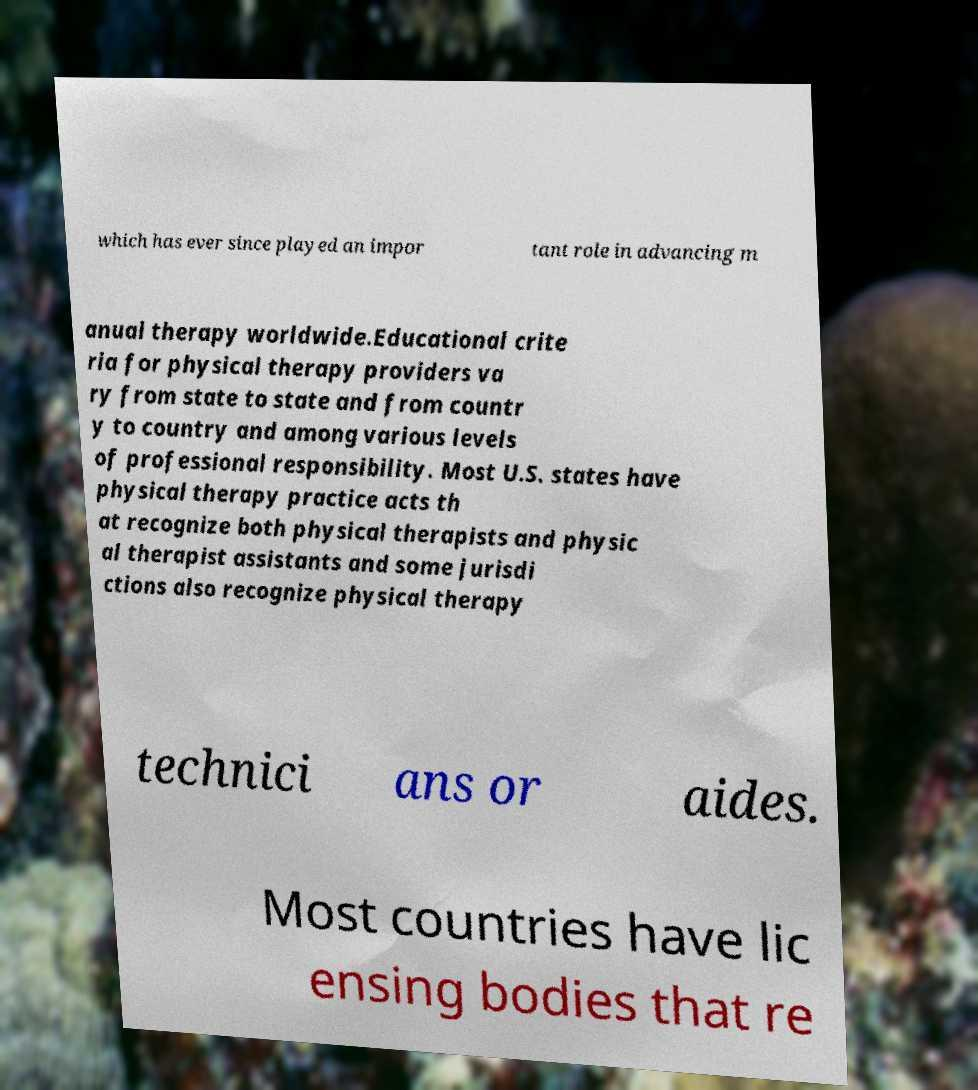Can you accurately transcribe the text from the provided image for me? which has ever since played an impor tant role in advancing m anual therapy worldwide.Educational crite ria for physical therapy providers va ry from state to state and from countr y to country and among various levels of professional responsibility. Most U.S. states have physical therapy practice acts th at recognize both physical therapists and physic al therapist assistants and some jurisdi ctions also recognize physical therapy technici ans or aides. Most countries have lic ensing bodies that re 